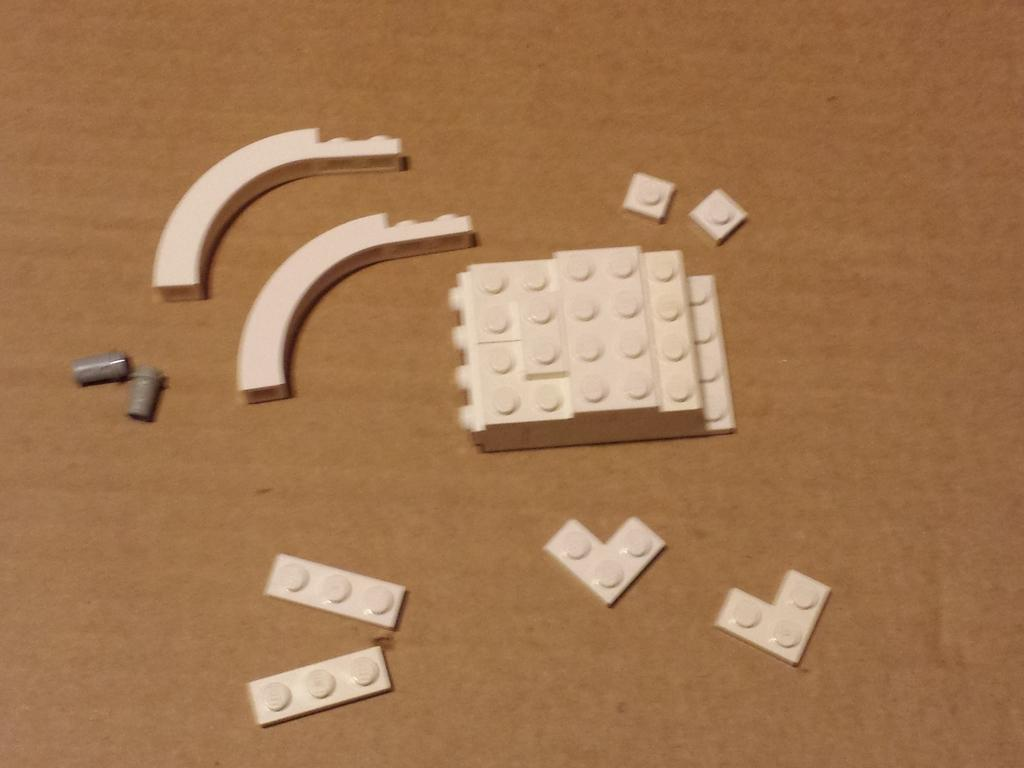What is placed on the table in the image? There are legos placed on a table. Can you describe the setting where the legos are located? The legos are placed on a table, which suggests it might be in a play area or a room designated for building and playing with legos. What type of hot blood is visible on the legos in the image? There is no blood, hot or otherwise, visible on the legos in the image. What type of chain can be seen connecting the legos in the image? There is no chain present in the image; it is a collection of legos placed on a table. 